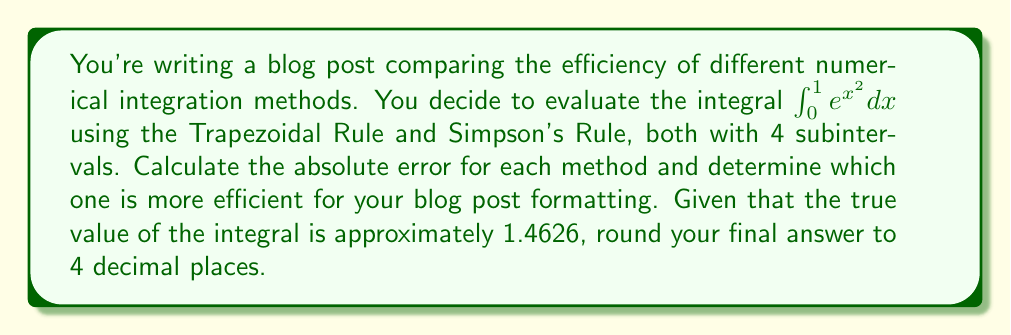Show me your answer to this math problem. 1. Divide the interval [0, 1] into 4 subintervals:
   $x_0 = 0, x_1 = 0.25, x_2 = 0.5, x_3 = 0.75, x_4 = 1$

2. Calculate $f(x_i) = e^{x_i^2}$ for each point:
   $f(x_0) = 1$
   $f(x_1) \approx 1.0645$
   $f(x_2) \approx 1.2840$
   $f(x_3) \approx 1.7561$
   $f(x_4) = e \approx 2.7183$

3. Trapezoidal Rule:
   $$T = \frac{h}{2}[f(x_0) + 2f(x_1) + 2f(x_2) + 2f(x_3) + f(x_4)]$$
   where $h = \frac{1}{4} = 0.25$
   
   $T = \frac{0.25}{2}[1 + 2(1.0645) + 2(1.2840) + 2(1.7561) + 2.7183]$
   $T \approx 1.4871$

4. Simpson's Rule:
   $$S = \frac{h}{3}[f(x_0) + 4f(x_1) + 2f(x_2) + 4f(x_3) + f(x_4)]$$
   
   $S = \frac{0.25}{3}[1 + 4(1.0645) + 2(1.2840) + 4(1.7561) + 2.7183]$
   $S \approx 1.4632$

5. Calculate absolute errors:
   Trapezoidal Rule: $|1.4871 - 1.4626| = 0.0245$
   Simpson's Rule: $|1.4632 - 1.4626| = 0.0006$

6. Compare errors:
   Simpson's Rule has a smaller absolute error (0.0006 < 0.0245)

7. Round the difference in errors to 4 decimal places:
   $0.0245 - 0.0006 = 0.0239$
Answer: 0.0239 